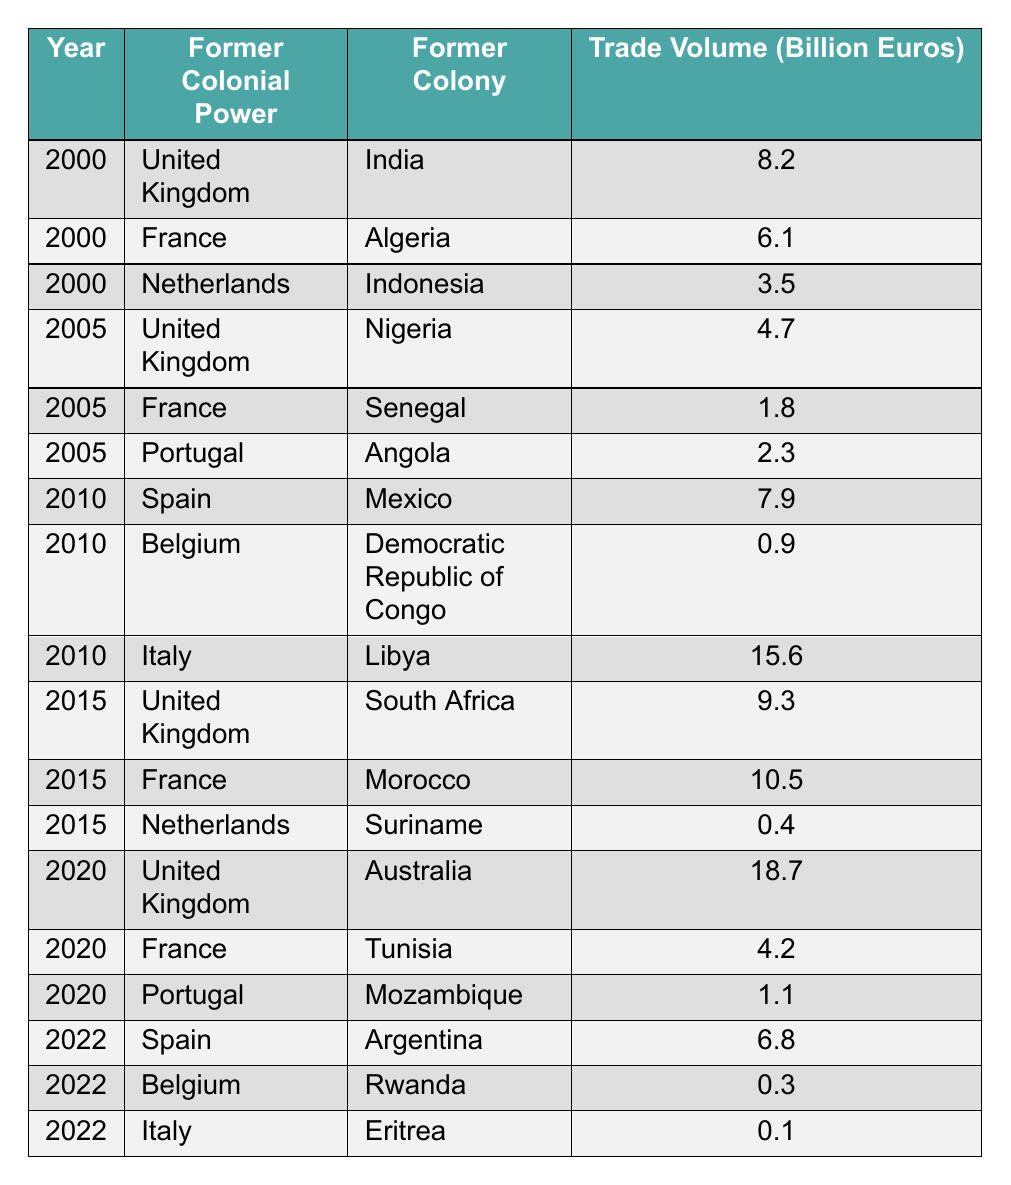What was the trade volume between the United Kingdom and India in 2000? The table shows the row for the year 2000 where the former colonial power is the United Kingdom and the former colony is India, listing a trade volume of 8.2 billion euros.
Answer: 8.2 billion euros Which former colony had the highest trade volume with Italy in 2010? In 2010, the table lists Italy with the former colony of Libya, which had a trade volume of 15.6 billion euros, the highest for Italy in that year.
Answer: Libya What was the total trade volume between France and its former colonies from 2000 to 2020? The trade volumes for France and its former colonies are 6.1 (Algeria in 2000), 1.8 (Senegal in 2005), 10.5 (Morocco in 2015), and 4.2 (Tunisia in 2020). Summing these values gives 6.1 + 1.8 + 10.5 + 4.2 = 22.6 billion euros.
Answer: 22.6 billion euros Did the trade volume between the United Kingdom and Australia in 2020 exceed the trade volume with India in 2000? The trade volume with Australia in 2020 is 18.7 billion euros and with India in 2000 is 8.2 billion euros. Since 18.7 is greater than 8.2, the statement is true.
Answer: Yes Which year saw the highest trade volume between the United Kingdom and any of its former colonies? The table shows the trade volumes for the UK with its former colonies: 8.2 billion euros (India in 2000), 4.7 (Nigeria in 2005), 9.3 (South Africa in 2015), and 18.7 (Australia in 2020). The highest is 18.7 billion euros in 2020.
Answer: 2020 What was the trade volume between Portugal and Mozambique in 2020? The table shows that in 2020, the trade volume between Portugal and its former colony Mozambique is 1.1 billion euros.
Answer: 1.1 billion euros How many different former colonies does France have listed in the table? The table lists four former colonies associated with France: Algeria, Senegal, Morocco, and Tunisia. Therefore, there are 4 distinct former colonies.
Answer: 4 Was the trade volume with Rwanda in 2022 greater than that with Libya in 2010? The trade volume with Rwanda in 2022 is 0.3 billion euros, while the trade volume with Libya in 2010 is 15.6 billion euros. Since 0.3 is less than 15.6, the statement is false.
Answer: No What is the average trade volume between Belgium and its former colonies from 2010 to 2022? Belgium's trade volumes with its former colonies are 0.9 billion euros (Democratic Republic of Congo in 2010) and 0.3 billion euros (Rwanda in 2022). To find the average, sum these values: 0.9 + 0.3 = 1.2 billion euros, then divide by 2 for the average: 1.2 / 2 = 0.6 billion euros.
Answer: 0.6 billion euros Which former colonial power had a trade volume with Angola in 2005? The table shows Portugal as the former colonial power with a trade volume of 2.3 billion euros with Angola in 2005.
Answer: Portugal 